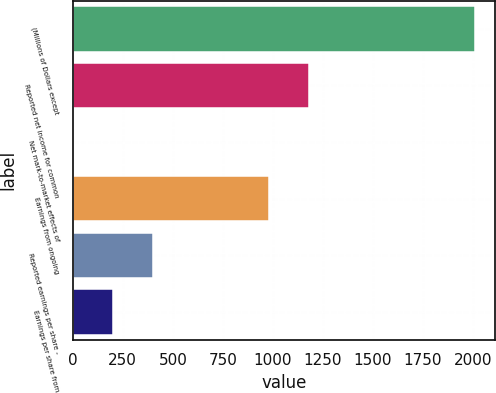<chart> <loc_0><loc_0><loc_500><loc_500><bar_chart><fcel>(Millions of Dollars except<fcel>Reported net income for common<fcel>Net mark-to-market effects of<fcel>Earnings from ongoing<fcel>Reported earnings per share -<fcel>Earnings per share from<nl><fcel>2010<fcel>1182<fcel>0.04<fcel>981<fcel>402.04<fcel>201.04<nl></chart> 